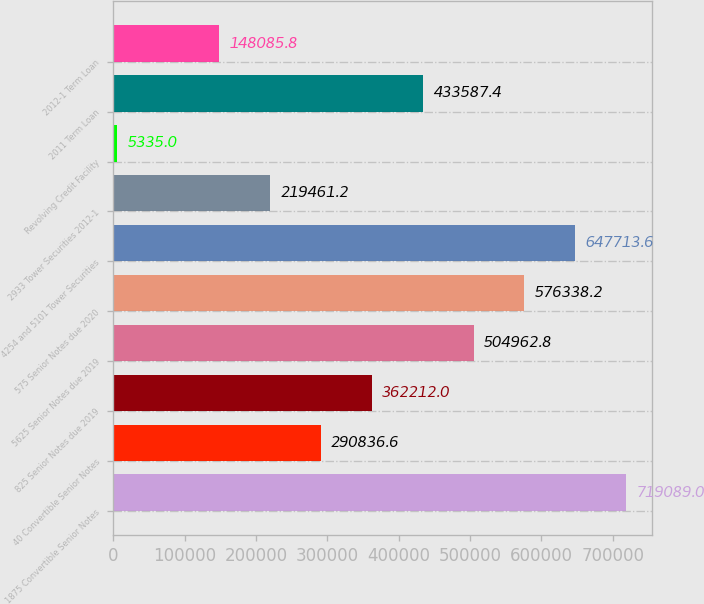Convert chart. <chart><loc_0><loc_0><loc_500><loc_500><bar_chart><fcel>1875 Convertible Senior Notes<fcel>40 Convertible Senior Notes<fcel>825 Senior Notes due 2019<fcel>5625 Senior Notes due 2019<fcel>575 Senior Notes due 2020<fcel>4254 and 5101 Tower Securities<fcel>2933 Tower Securities 2012-1<fcel>Revolving Credit Facility<fcel>2011 Term Loan<fcel>2012-1 Term Loan<nl><fcel>719089<fcel>290837<fcel>362212<fcel>504963<fcel>576338<fcel>647714<fcel>219461<fcel>5335<fcel>433587<fcel>148086<nl></chart> 